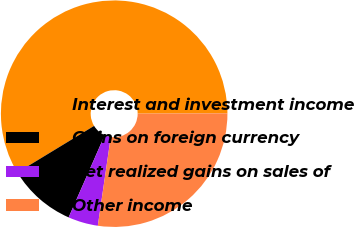Convert chart. <chart><loc_0><loc_0><loc_500><loc_500><pie_chart><fcel>Interest and investment income<fcel>Gains on foreign currency<fcel>Net realized gains on sales of<fcel>Other income<nl><fcel>58.64%<fcel>9.72%<fcel>4.28%<fcel>27.36%<nl></chart> 